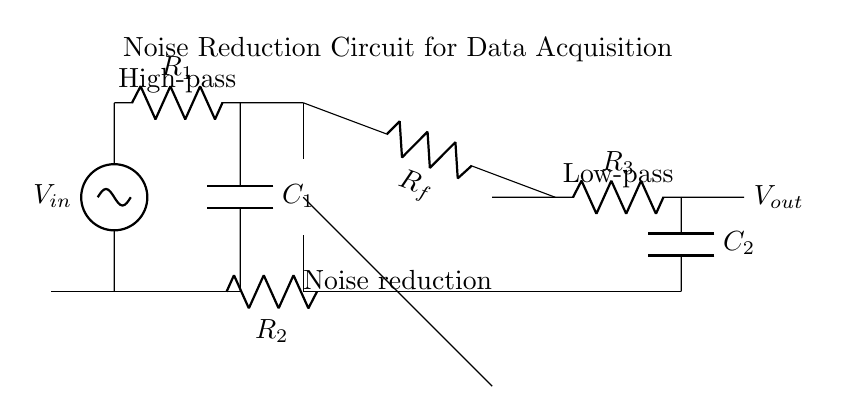What is the input voltage of the circuit? The input voltage is labeled as V_in, which is the potential applied at the upper terminal of the circuit.
Answer: V_in What type of filter is shown at the input stage? The circuit includes a high-pass filter consisting of a resistor and capacitor, which blocks low-frequency signals while allowing high-frequency signals to pass through.
Answer: High-pass filter How many operational amplifiers are used in this circuit? There is one operational amplifier depicted in the circuit, identified as the op amp symbol between the feedback and input stages.
Answer: One What component is used for feedback in the op-amp stage? The feedback is provided by the resistor labeled R_f, which connects the output of the op-amp to its inverting input to control gain and stability.
Answer: R_f What is the output voltage of this circuit? The output is denoted as V_out, which is the voltage after processing by both the high-pass filter and the low-pass filter stages of the circuit.
Answer: V_out What is the purpose of the added R_2 resistor in the circuit? R_2 serves as a load resistor connected to the non-inverting input of the op-amp, helping to set the gain and stabilize the circuit by providing a path for the input signal.
Answer: Load resistor Which stage of the circuit reduces low-frequency noise? The low-pass filter, composed of the resistor R_3 and capacitor C_2, allows low-frequency signals to pass but attenuates higher-frequency noise.
Answer: Low-pass filter 